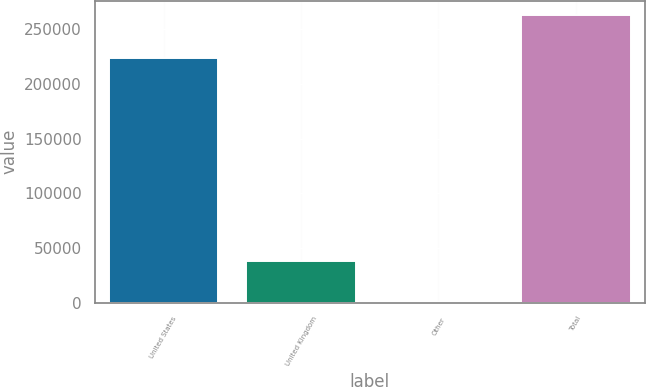Convert chart. <chart><loc_0><loc_0><loc_500><loc_500><bar_chart><fcel>United States<fcel>United Kingdom<fcel>Other<fcel>Total<nl><fcel>223741<fcel>38189<fcel>844<fcel>262774<nl></chart> 